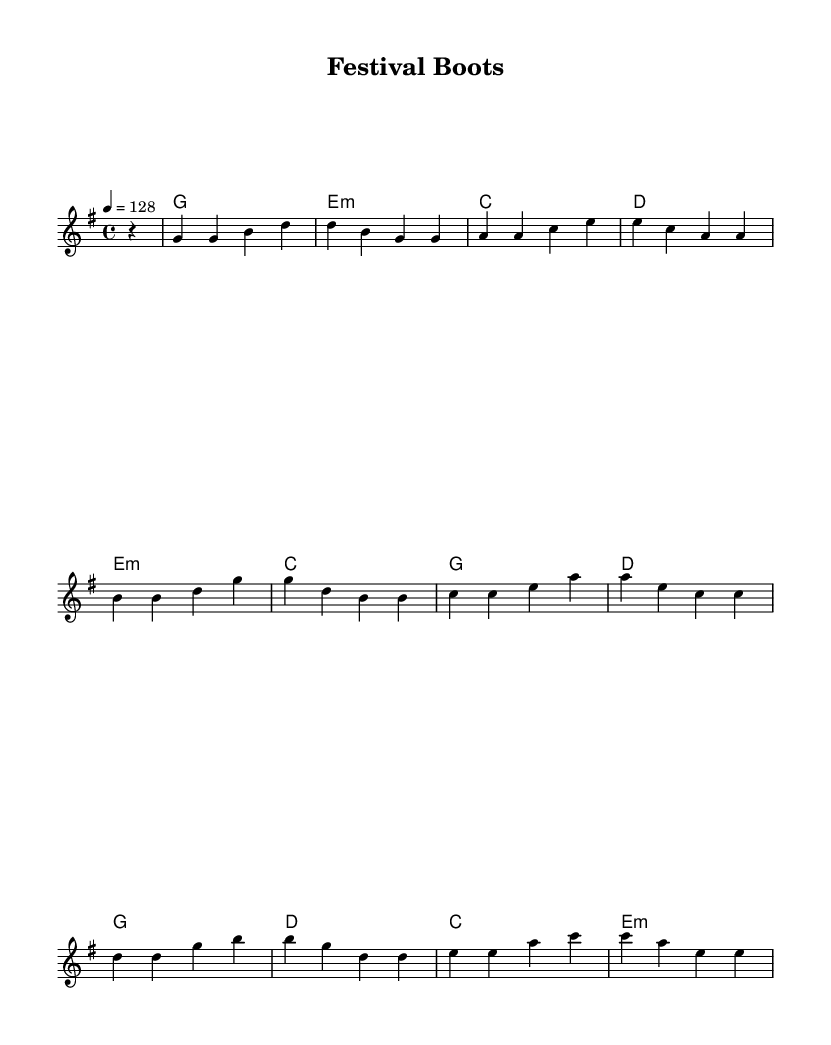What is the key signature of this music? The key signature indicated in the piece is G major, which has one sharp (F#). This can be identified at the beginning of the sheet music where the key signature is shown.
Answer: G major What is the time signature of this music? The time signature displayed is 4/4, meaning there are four beats per measure and a quarter note gets one beat. This is located near the beginning of the sheet music.
Answer: 4/4 What is the tempo marking for this piece? The tempo marking is 128 beats per minute, as indicated by the tempo indication at the start of the music. It suggests the pace at which the piece should be played.
Answer: 128 What is the first chord in the verse? The first chord in the verse is G major. By looking at the chord symbols above the melody, the first chord listed corresponds to the start of the melody.
Answer: G How many sections does the song have? The song consists of three main sections: Verse, Pre-Chorus, and Chorus. By analyzing the structure marked in the music, we can see these distinct sections laid out sequentially.
Answer: Three Which chord follows the G major chord in the chorus? The chord following the G major in the chorus is D major. By looking at the chord progression outlined in the sheet music during the chorus section, we can identify the sequence of chords.
Answer: D What element makes this piece suitable for festival crowds? The upbeat tempo of 128 beats per minute contributes significantly to making this piece suitable for festival crowds, creating an energetic and danceable atmosphere. This is inferred from the overall lively vibe conveyed through the notation and tempo marking.
Answer: Upbeat tempo 